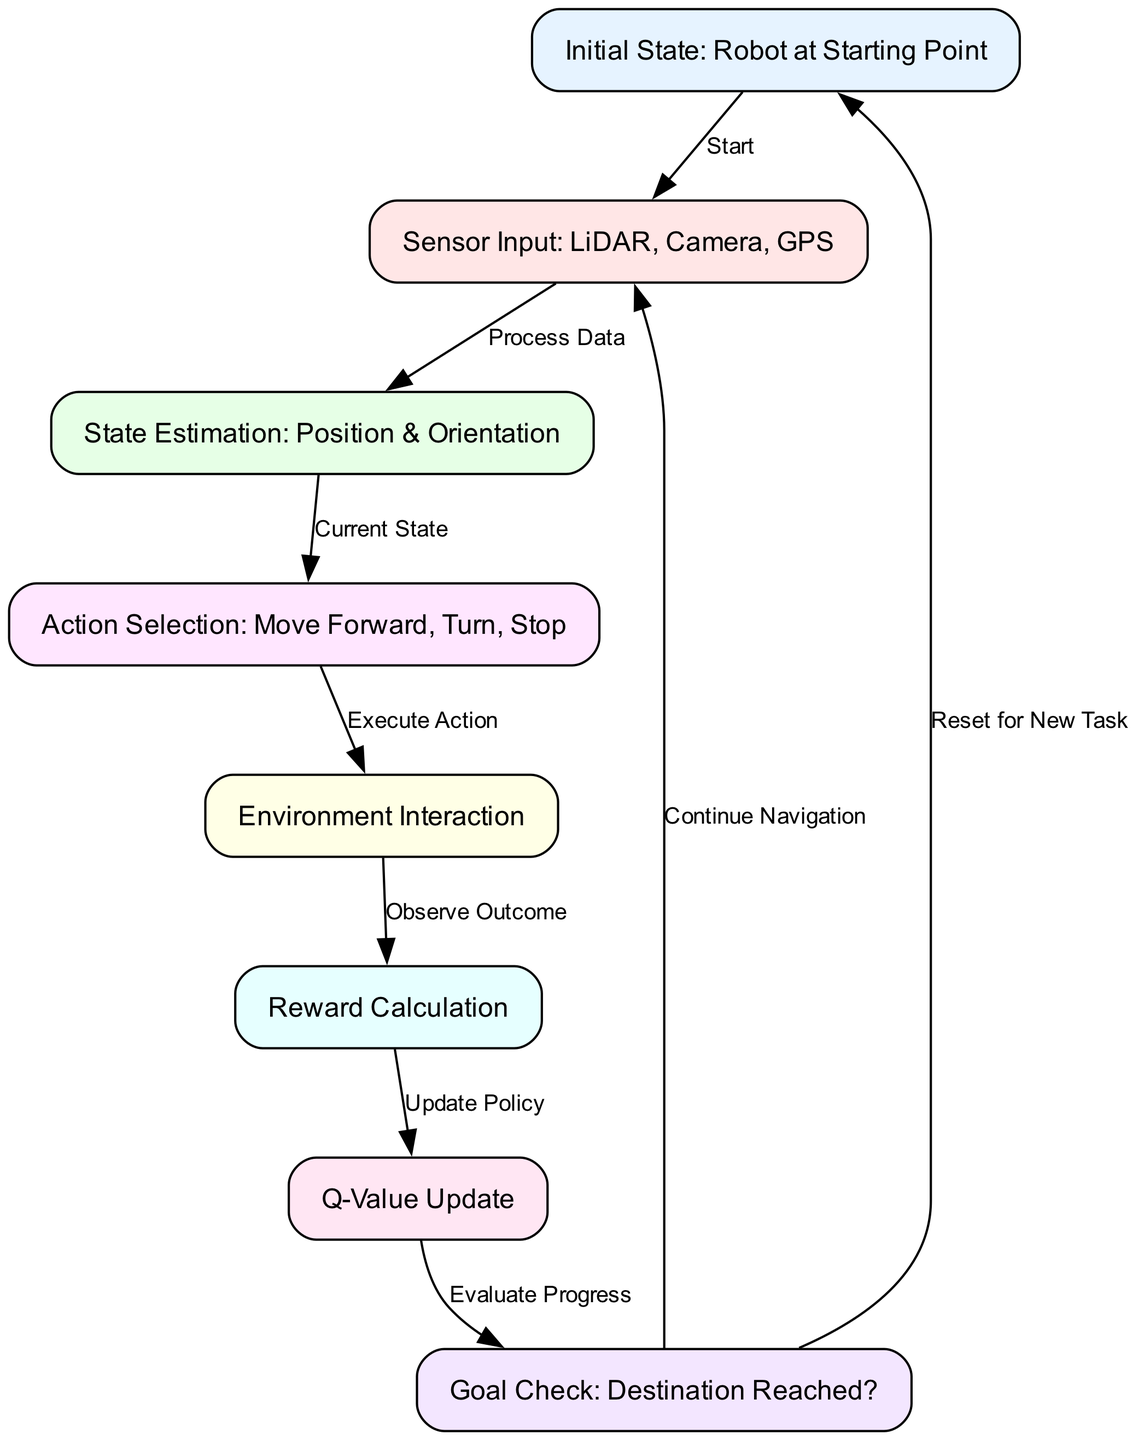What is the first node in the flowchart? The first node in the flowchart is labeled "Initial State: Robot at Starting Point," as it is where the process begins and leads to the subsequent nodes.
Answer: Initial State: Robot at Starting Point How many nodes are present in the diagram? By counting the nodes listed in the data, there are a total of 8 nodes in the diagram that describe different stages of the reinforcement learning process.
Answer: 8 What action can the robot take after "Action Selection"? After "Action Selection," the next step is "Environment Interaction," indicating that the robot chooses to engage with its surroundings based on the selected action.
Answer: Environment Interaction What does the edge from "Reward Calculation" to "Q-Value Update" represent? The edge represents the process of transitioning from calculating rewards back to updating Q-values based on the received feedback from the environment after executing an action.
Answer: Update Policy What condition is checked after the reward calculation? The condition checked is whether the destination has been reached, as indicated by the node "Goal Check: Destination Reached?" This is an essential step in evaluating the completion of the navigation task.
Answer: Goal Check: Destination Reached? What happens if the goal is not reached? If the goal is not achieved, the flowchart indicates that the system continues navigation by going back to the "Sensor Input" phase, allowing for further processing of sensor data to correct the path.
Answer: Continue Navigation Which two nodes are connected by an edge labeled "Process Data"? The edge labeled "Process Data" connects the nodes "Sensor Input: LiDAR, Camera, GPS" and "State Estimation: Position & Orientation," showing that the data collected by the sensors is processed to estimate the robot's current state.
Answer: Sensor Input: LiDAR, Camera, GPS and State Estimation: Position & Orientation If the robot completes its task, what is the next step as per the flowchart? Upon completing its task, the robot has the option to reset for a new task, leading back to the "Initial State" node where the process can begin anew for another navigation challenge.
Answer: Reset for New Task 